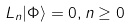Convert formula to latex. <formula><loc_0><loc_0><loc_500><loc_500>L _ { n } | \Phi \rangle = 0 , n \geq 0</formula> 